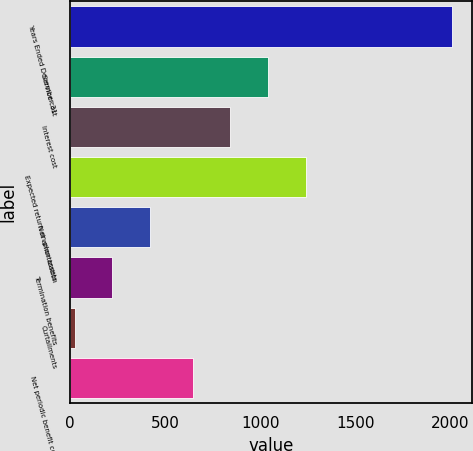Convert chart to OTSL. <chart><loc_0><loc_0><loc_500><loc_500><bar_chart><fcel>Years Ended December 31<fcel>Service cost<fcel>Interest cost<fcel>Expected return on plan assets<fcel>Net amortization<fcel>Termination benefits<fcel>Curtailments<fcel>Net periodic benefit cost<nl><fcel>2013<fcel>1042<fcel>843<fcel>1241<fcel>421<fcel>222<fcel>23<fcel>644<nl></chart> 